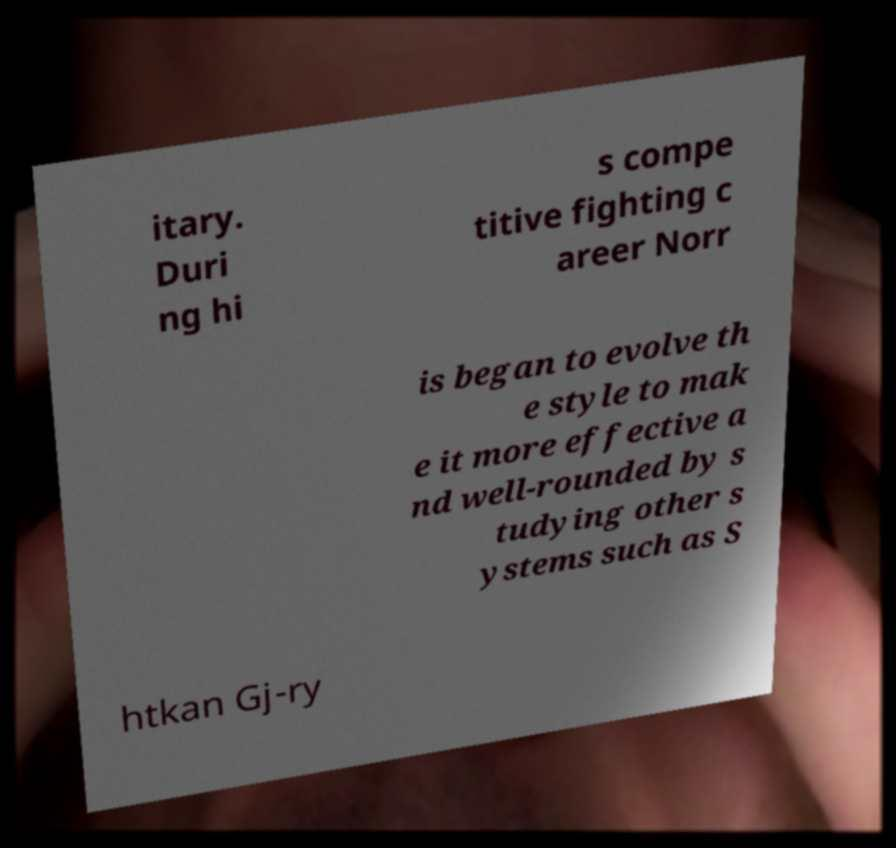Can you read and provide the text displayed in the image?This photo seems to have some interesting text. Can you extract and type it out for me? itary. Duri ng hi s compe titive fighting c areer Norr is began to evolve th e style to mak e it more effective a nd well-rounded by s tudying other s ystems such as S htkan Gj-ry 